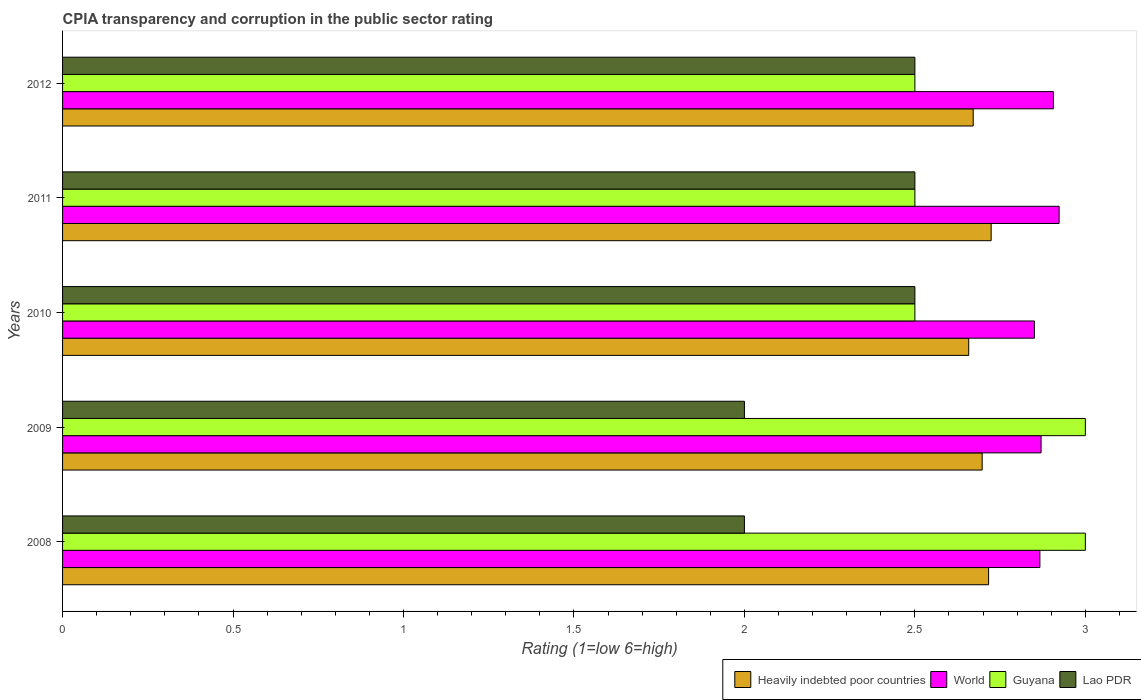Are the number of bars on each tick of the Y-axis equal?
Give a very brief answer. Yes. How many bars are there on the 5th tick from the top?
Give a very brief answer. 4. In how many cases, is the number of bars for a given year not equal to the number of legend labels?
Ensure brevity in your answer.  0. What is the CPIA rating in Heavily indebted poor countries in 2010?
Keep it short and to the point. 2.66. Across all years, what is the maximum CPIA rating in Heavily indebted poor countries?
Ensure brevity in your answer.  2.72. Across all years, what is the minimum CPIA rating in Guyana?
Make the answer very short. 2.5. In which year was the CPIA rating in Heavily indebted poor countries maximum?
Your answer should be very brief. 2011. In which year was the CPIA rating in Guyana minimum?
Your answer should be compact. 2010. What is the difference between the CPIA rating in Heavily indebted poor countries in 2008 and that in 2011?
Give a very brief answer. -0.01. What is the difference between the CPIA rating in Lao PDR in 2009 and the CPIA rating in Guyana in 2012?
Your answer should be very brief. -0.5. In the year 2010, what is the difference between the CPIA rating in World and CPIA rating in Heavily indebted poor countries?
Offer a terse response. 0.19. In how many years, is the CPIA rating in World greater than 0.8 ?
Your answer should be compact. 5. What is the ratio of the CPIA rating in Heavily indebted poor countries in 2008 to that in 2011?
Keep it short and to the point. 1. Is the CPIA rating in Lao PDR in 2010 less than that in 2011?
Make the answer very short. No. Is the difference between the CPIA rating in World in 2008 and 2010 greater than the difference between the CPIA rating in Heavily indebted poor countries in 2008 and 2010?
Provide a short and direct response. No. What is the difference between the highest and the lowest CPIA rating in Heavily indebted poor countries?
Make the answer very short. 0.07. What does the 4th bar from the top in 2009 represents?
Your answer should be very brief. Heavily indebted poor countries. What does the 1st bar from the bottom in 2011 represents?
Offer a terse response. Heavily indebted poor countries. How many bars are there?
Your response must be concise. 20. Are the values on the major ticks of X-axis written in scientific E-notation?
Provide a short and direct response. No. Does the graph contain any zero values?
Provide a short and direct response. No. Where does the legend appear in the graph?
Offer a very short reply. Bottom right. What is the title of the graph?
Keep it short and to the point. CPIA transparency and corruption in the public sector rating. Does "Singapore" appear as one of the legend labels in the graph?
Provide a short and direct response. No. What is the label or title of the X-axis?
Your answer should be compact. Rating (1=low 6=high). What is the Rating (1=low 6=high) of Heavily indebted poor countries in 2008?
Offer a very short reply. 2.72. What is the Rating (1=low 6=high) of World in 2008?
Provide a short and direct response. 2.87. What is the Rating (1=low 6=high) in Lao PDR in 2008?
Your answer should be very brief. 2. What is the Rating (1=low 6=high) of Heavily indebted poor countries in 2009?
Keep it short and to the point. 2.7. What is the Rating (1=low 6=high) in World in 2009?
Provide a short and direct response. 2.87. What is the Rating (1=low 6=high) in Guyana in 2009?
Provide a short and direct response. 3. What is the Rating (1=low 6=high) of Lao PDR in 2009?
Your response must be concise. 2. What is the Rating (1=low 6=high) of Heavily indebted poor countries in 2010?
Ensure brevity in your answer.  2.66. What is the Rating (1=low 6=high) of World in 2010?
Make the answer very short. 2.85. What is the Rating (1=low 6=high) in Lao PDR in 2010?
Ensure brevity in your answer.  2.5. What is the Rating (1=low 6=high) of Heavily indebted poor countries in 2011?
Make the answer very short. 2.72. What is the Rating (1=low 6=high) in World in 2011?
Keep it short and to the point. 2.92. What is the Rating (1=low 6=high) of Lao PDR in 2011?
Provide a short and direct response. 2.5. What is the Rating (1=low 6=high) of Heavily indebted poor countries in 2012?
Provide a short and direct response. 2.67. What is the Rating (1=low 6=high) in World in 2012?
Keep it short and to the point. 2.91. What is the Rating (1=low 6=high) in Lao PDR in 2012?
Provide a short and direct response. 2.5. Across all years, what is the maximum Rating (1=low 6=high) in Heavily indebted poor countries?
Your answer should be compact. 2.72. Across all years, what is the maximum Rating (1=low 6=high) in World?
Your answer should be compact. 2.92. Across all years, what is the maximum Rating (1=low 6=high) of Guyana?
Keep it short and to the point. 3. Across all years, what is the minimum Rating (1=low 6=high) in Heavily indebted poor countries?
Your response must be concise. 2.66. Across all years, what is the minimum Rating (1=low 6=high) in World?
Your answer should be compact. 2.85. Across all years, what is the minimum Rating (1=low 6=high) of Guyana?
Your response must be concise. 2.5. What is the total Rating (1=low 6=high) in Heavily indebted poor countries in the graph?
Provide a succinct answer. 13.47. What is the total Rating (1=low 6=high) in World in the graph?
Offer a very short reply. 14.42. What is the total Rating (1=low 6=high) of Lao PDR in the graph?
Provide a short and direct response. 11.5. What is the difference between the Rating (1=low 6=high) of Heavily indebted poor countries in 2008 and that in 2009?
Your response must be concise. 0.02. What is the difference between the Rating (1=low 6=high) in World in 2008 and that in 2009?
Provide a succinct answer. -0. What is the difference between the Rating (1=low 6=high) in Guyana in 2008 and that in 2009?
Provide a succinct answer. 0. What is the difference between the Rating (1=low 6=high) of Heavily indebted poor countries in 2008 and that in 2010?
Offer a terse response. 0.06. What is the difference between the Rating (1=low 6=high) in World in 2008 and that in 2010?
Your answer should be compact. 0.02. What is the difference between the Rating (1=low 6=high) in Heavily indebted poor countries in 2008 and that in 2011?
Provide a succinct answer. -0.01. What is the difference between the Rating (1=low 6=high) of World in 2008 and that in 2011?
Provide a succinct answer. -0.06. What is the difference between the Rating (1=low 6=high) in Heavily indebted poor countries in 2008 and that in 2012?
Offer a very short reply. 0.05. What is the difference between the Rating (1=low 6=high) of World in 2008 and that in 2012?
Your response must be concise. -0.04. What is the difference between the Rating (1=low 6=high) in Guyana in 2008 and that in 2012?
Make the answer very short. 0.5. What is the difference between the Rating (1=low 6=high) in Heavily indebted poor countries in 2009 and that in 2010?
Ensure brevity in your answer.  0.04. What is the difference between the Rating (1=low 6=high) of World in 2009 and that in 2010?
Ensure brevity in your answer.  0.02. What is the difference between the Rating (1=low 6=high) in Lao PDR in 2009 and that in 2010?
Keep it short and to the point. -0.5. What is the difference between the Rating (1=low 6=high) of Heavily indebted poor countries in 2009 and that in 2011?
Offer a terse response. -0.03. What is the difference between the Rating (1=low 6=high) in World in 2009 and that in 2011?
Offer a very short reply. -0.05. What is the difference between the Rating (1=low 6=high) in Guyana in 2009 and that in 2011?
Offer a terse response. 0.5. What is the difference between the Rating (1=low 6=high) of Heavily indebted poor countries in 2009 and that in 2012?
Keep it short and to the point. 0.03. What is the difference between the Rating (1=low 6=high) in World in 2009 and that in 2012?
Provide a short and direct response. -0.04. What is the difference between the Rating (1=low 6=high) in Heavily indebted poor countries in 2010 and that in 2011?
Give a very brief answer. -0.07. What is the difference between the Rating (1=low 6=high) in World in 2010 and that in 2011?
Your answer should be compact. -0.07. What is the difference between the Rating (1=low 6=high) in Guyana in 2010 and that in 2011?
Provide a short and direct response. 0. What is the difference between the Rating (1=low 6=high) in Lao PDR in 2010 and that in 2011?
Give a very brief answer. 0. What is the difference between the Rating (1=low 6=high) of Heavily indebted poor countries in 2010 and that in 2012?
Your response must be concise. -0.01. What is the difference between the Rating (1=low 6=high) in World in 2010 and that in 2012?
Your response must be concise. -0.06. What is the difference between the Rating (1=low 6=high) in Guyana in 2010 and that in 2012?
Provide a short and direct response. 0. What is the difference between the Rating (1=low 6=high) in Heavily indebted poor countries in 2011 and that in 2012?
Make the answer very short. 0.05. What is the difference between the Rating (1=low 6=high) in World in 2011 and that in 2012?
Your answer should be compact. 0.02. What is the difference between the Rating (1=low 6=high) of Heavily indebted poor countries in 2008 and the Rating (1=low 6=high) of World in 2009?
Make the answer very short. -0.15. What is the difference between the Rating (1=low 6=high) in Heavily indebted poor countries in 2008 and the Rating (1=low 6=high) in Guyana in 2009?
Provide a short and direct response. -0.28. What is the difference between the Rating (1=low 6=high) in Heavily indebted poor countries in 2008 and the Rating (1=low 6=high) in Lao PDR in 2009?
Make the answer very short. 0.72. What is the difference between the Rating (1=low 6=high) in World in 2008 and the Rating (1=low 6=high) in Guyana in 2009?
Your answer should be very brief. -0.13. What is the difference between the Rating (1=low 6=high) in World in 2008 and the Rating (1=low 6=high) in Lao PDR in 2009?
Keep it short and to the point. 0.87. What is the difference between the Rating (1=low 6=high) in Guyana in 2008 and the Rating (1=low 6=high) in Lao PDR in 2009?
Offer a very short reply. 1. What is the difference between the Rating (1=low 6=high) of Heavily indebted poor countries in 2008 and the Rating (1=low 6=high) of World in 2010?
Keep it short and to the point. -0.13. What is the difference between the Rating (1=low 6=high) in Heavily indebted poor countries in 2008 and the Rating (1=low 6=high) in Guyana in 2010?
Ensure brevity in your answer.  0.22. What is the difference between the Rating (1=low 6=high) in Heavily indebted poor countries in 2008 and the Rating (1=low 6=high) in Lao PDR in 2010?
Offer a terse response. 0.22. What is the difference between the Rating (1=low 6=high) of World in 2008 and the Rating (1=low 6=high) of Guyana in 2010?
Offer a terse response. 0.37. What is the difference between the Rating (1=low 6=high) in World in 2008 and the Rating (1=low 6=high) in Lao PDR in 2010?
Your answer should be compact. 0.37. What is the difference between the Rating (1=low 6=high) in Heavily indebted poor countries in 2008 and the Rating (1=low 6=high) in World in 2011?
Keep it short and to the point. -0.21. What is the difference between the Rating (1=low 6=high) of Heavily indebted poor countries in 2008 and the Rating (1=low 6=high) of Guyana in 2011?
Offer a very short reply. 0.22. What is the difference between the Rating (1=low 6=high) in Heavily indebted poor countries in 2008 and the Rating (1=low 6=high) in Lao PDR in 2011?
Your answer should be compact. 0.22. What is the difference between the Rating (1=low 6=high) in World in 2008 and the Rating (1=low 6=high) in Guyana in 2011?
Keep it short and to the point. 0.37. What is the difference between the Rating (1=low 6=high) in World in 2008 and the Rating (1=low 6=high) in Lao PDR in 2011?
Provide a short and direct response. 0.37. What is the difference between the Rating (1=low 6=high) of Heavily indebted poor countries in 2008 and the Rating (1=low 6=high) of World in 2012?
Your answer should be very brief. -0.19. What is the difference between the Rating (1=low 6=high) of Heavily indebted poor countries in 2008 and the Rating (1=low 6=high) of Guyana in 2012?
Ensure brevity in your answer.  0.22. What is the difference between the Rating (1=low 6=high) in Heavily indebted poor countries in 2008 and the Rating (1=low 6=high) in Lao PDR in 2012?
Give a very brief answer. 0.22. What is the difference between the Rating (1=low 6=high) of World in 2008 and the Rating (1=low 6=high) of Guyana in 2012?
Offer a terse response. 0.37. What is the difference between the Rating (1=low 6=high) of World in 2008 and the Rating (1=low 6=high) of Lao PDR in 2012?
Make the answer very short. 0.37. What is the difference between the Rating (1=low 6=high) of Heavily indebted poor countries in 2009 and the Rating (1=low 6=high) of World in 2010?
Your answer should be very brief. -0.15. What is the difference between the Rating (1=low 6=high) of Heavily indebted poor countries in 2009 and the Rating (1=low 6=high) of Guyana in 2010?
Keep it short and to the point. 0.2. What is the difference between the Rating (1=low 6=high) in Heavily indebted poor countries in 2009 and the Rating (1=low 6=high) in Lao PDR in 2010?
Offer a terse response. 0.2. What is the difference between the Rating (1=low 6=high) of World in 2009 and the Rating (1=low 6=high) of Guyana in 2010?
Ensure brevity in your answer.  0.37. What is the difference between the Rating (1=low 6=high) of World in 2009 and the Rating (1=low 6=high) of Lao PDR in 2010?
Your response must be concise. 0.37. What is the difference between the Rating (1=low 6=high) in Heavily indebted poor countries in 2009 and the Rating (1=low 6=high) in World in 2011?
Ensure brevity in your answer.  -0.23. What is the difference between the Rating (1=low 6=high) of Heavily indebted poor countries in 2009 and the Rating (1=low 6=high) of Guyana in 2011?
Offer a terse response. 0.2. What is the difference between the Rating (1=low 6=high) of Heavily indebted poor countries in 2009 and the Rating (1=low 6=high) of Lao PDR in 2011?
Your answer should be very brief. 0.2. What is the difference between the Rating (1=low 6=high) in World in 2009 and the Rating (1=low 6=high) in Guyana in 2011?
Your answer should be very brief. 0.37. What is the difference between the Rating (1=low 6=high) of World in 2009 and the Rating (1=low 6=high) of Lao PDR in 2011?
Keep it short and to the point. 0.37. What is the difference between the Rating (1=low 6=high) of Heavily indebted poor countries in 2009 and the Rating (1=low 6=high) of World in 2012?
Your answer should be very brief. -0.21. What is the difference between the Rating (1=low 6=high) in Heavily indebted poor countries in 2009 and the Rating (1=low 6=high) in Guyana in 2012?
Offer a very short reply. 0.2. What is the difference between the Rating (1=low 6=high) of Heavily indebted poor countries in 2009 and the Rating (1=low 6=high) of Lao PDR in 2012?
Provide a succinct answer. 0.2. What is the difference between the Rating (1=low 6=high) of World in 2009 and the Rating (1=low 6=high) of Guyana in 2012?
Provide a short and direct response. 0.37. What is the difference between the Rating (1=low 6=high) of World in 2009 and the Rating (1=low 6=high) of Lao PDR in 2012?
Keep it short and to the point. 0.37. What is the difference between the Rating (1=low 6=high) of Guyana in 2009 and the Rating (1=low 6=high) of Lao PDR in 2012?
Provide a short and direct response. 0.5. What is the difference between the Rating (1=low 6=high) in Heavily indebted poor countries in 2010 and the Rating (1=low 6=high) in World in 2011?
Provide a succinct answer. -0.27. What is the difference between the Rating (1=low 6=high) of Heavily indebted poor countries in 2010 and the Rating (1=low 6=high) of Guyana in 2011?
Your answer should be very brief. 0.16. What is the difference between the Rating (1=low 6=high) of Heavily indebted poor countries in 2010 and the Rating (1=low 6=high) of Lao PDR in 2011?
Ensure brevity in your answer.  0.16. What is the difference between the Rating (1=low 6=high) in World in 2010 and the Rating (1=low 6=high) in Guyana in 2011?
Provide a succinct answer. 0.35. What is the difference between the Rating (1=low 6=high) of World in 2010 and the Rating (1=low 6=high) of Lao PDR in 2011?
Offer a terse response. 0.35. What is the difference between the Rating (1=low 6=high) in Guyana in 2010 and the Rating (1=low 6=high) in Lao PDR in 2011?
Provide a succinct answer. 0. What is the difference between the Rating (1=low 6=high) of Heavily indebted poor countries in 2010 and the Rating (1=low 6=high) of World in 2012?
Your answer should be compact. -0.25. What is the difference between the Rating (1=low 6=high) in Heavily indebted poor countries in 2010 and the Rating (1=low 6=high) in Guyana in 2012?
Give a very brief answer. 0.16. What is the difference between the Rating (1=low 6=high) of Heavily indebted poor countries in 2010 and the Rating (1=low 6=high) of Lao PDR in 2012?
Your answer should be very brief. 0.16. What is the difference between the Rating (1=low 6=high) in World in 2010 and the Rating (1=low 6=high) in Guyana in 2012?
Offer a terse response. 0.35. What is the difference between the Rating (1=low 6=high) in World in 2010 and the Rating (1=low 6=high) in Lao PDR in 2012?
Offer a very short reply. 0.35. What is the difference between the Rating (1=low 6=high) in Heavily indebted poor countries in 2011 and the Rating (1=low 6=high) in World in 2012?
Your response must be concise. -0.18. What is the difference between the Rating (1=low 6=high) in Heavily indebted poor countries in 2011 and the Rating (1=low 6=high) in Guyana in 2012?
Give a very brief answer. 0.22. What is the difference between the Rating (1=low 6=high) in Heavily indebted poor countries in 2011 and the Rating (1=low 6=high) in Lao PDR in 2012?
Give a very brief answer. 0.22. What is the difference between the Rating (1=low 6=high) of World in 2011 and the Rating (1=low 6=high) of Guyana in 2012?
Offer a very short reply. 0.42. What is the difference between the Rating (1=low 6=high) of World in 2011 and the Rating (1=low 6=high) of Lao PDR in 2012?
Keep it short and to the point. 0.42. What is the difference between the Rating (1=low 6=high) in Guyana in 2011 and the Rating (1=low 6=high) in Lao PDR in 2012?
Your response must be concise. 0. What is the average Rating (1=low 6=high) of Heavily indebted poor countries per year?
Provide a short and direct response. 2.69. What is the average Rating (1=low 6=high) in World per year?
Give a very brief answer. 2.88. What is the average Rating (1=low 6=high) of Guyana per year?
Make the answer very short. 2.7. In the year 2008, what is the difference between the Rating (1=low 6=high) in Heavily indebted poor countries and Rating (1=low 6=high) in World?
Provide a succinct answer. -0.15. In the year 2008, what is the difference between the Rating (1=low 6=high) in Heavily indebted poor countries and Rating (1=low 6=high) in Guyana?
Provide a short and direct response. -0.28. In the year 2008, what is the difference between the Rating (1=low 6=high) of Heavily indebted poor countries and Rating (1=low 6=high) of Lao PDR?
Provide a short and direct response. 0.72. In the year 2008, what is the difference between the Rating (1=low 6=high) in World and Rating (1=low 6=high) in Guyana?
Your answer should be very brief. -0.13. In the year 2008, what is the difference between the Rating (1=low 6=high) of World and Rating (1=low 6=high) of Lao PDR?
Your answer should be very brief. 0.87. In the year 2008, what is the difference between the Rating (1=low 6=high) of Guyana and Rating (1=low 6=high) of Lao PDR?
Provide a short and direct response. 1. In the year 2009, what is the difference between the Rating (1=low 6=high) of Heavily indebted poor countries and Rating (1=low 6=high) of World?
Your answer should be compact. -0.17. In the year 2009, what is the difference between the Rating (1=low 6=high) of Heavily indebted poor countries and Rating (1=low 6=high) of Guyana?
Your answer should be very brief. -0.3. In the year 2009, what is the difference between the Rating (1=low 6=high) of Heavily indebted poor countries and Rating (1=low 6=high) of Lao PDR?
Your response must be concise. 0.7. In the year 2009, what is the difference between the Rating (1=low 6=high) of World and Rating (1=low 6=high) of Guyana?
Make the answer very short. -0.13. In the year 2009, what is the difference between the Rating (1=low 6=high) in World and Rating (1=low 6=high) in Lao PDR?
Provide a succinct answer. 0.87. In the year 2009, what is the difference between the Rating (1=low 6=high) in Guyana and Rating (1=low 6=high) in Lao PDR?
Keep it short and to the point. 1. In the year 2010, what is the difference between the Rating (1=low 6=high) in Heavily indebted poor countries and Rating (1=low 6=high) in World?
Provide a short and direct response. -0.19. In the year 2010, what is the difference between the Rating (1=low 6=high) of Heavily indebted poor countries and Rating (1=low 6=high) of Guyana?
Provide a succinct answer. 0.16. In the year 2010, what is the difference between the Rating (1=low 6=high) of Heavily indebted poor countries and Rating (1=low 6=high) of Lao PDR?
Provide a short and direct response. 0.16. In the year 2010, what is the difference between the Rating (1=low 6=high) of World and Rating (1=low 6=high) of Guyana?
Keep it short and to the point. 0.35. In the year 2010, what is the difference between the Rating (1=low 6=high) in World and Rating (1=low 6=high) in Lao PDR?
Give a very brief answer. 0.35. In the year 2011, what is the difference between the Rating (1=low 6=high) in Heavily indebted poor countries and Rating (1=low 6=high) in World?
Your answer should be very brief. -0.2. In the year 2011, what is the difference between the Rating (1=low 6=high) in Heavily indebted poor countries and Rating (1=low 6=high) in Guyana?
Keep it short and to the point. 0.22. In the year 2011, what is the difference between the Rating (1=low 6=high) of Heavily indebted poor countries and Rating (1=low 6=high) of Lao PDR?
Provide a short and direct response. 0.22. In the year 2011, what is the difference between the Rating (1=low 6=high) of World and Rating (1=low 6=high) of Guyana?
Ensure brevity in your answer.  0.42. In the year 2011, what is the difference between the Rating (1=low 6=high) in World and Rating (1=low 6=high) in Lao PDR?
Your answer should be compact. 0.42. In the year 2011, what is the difference between the Rating (1=low 6=high) in Guyana and Rating (1=low 6=high) in Lao PDR?
Keep it short and to the point. 0. In the year 2012, what is the difference between the Rating (1=low 6=high) in Heavily indebted poor countries and Rating (1=low 6=high) in World?
Your answer should be very brief. -0.24. In the year 2012, what is the difference between the Rating (1=low 6=high) of Heavily indebted poor countries and Rating (1=low 6=high) of Guyana?
Your response must be concise. 0.17. In the year 2012, what is the difference between the Rating (1=low 6=high) of Heavily indebted poor countries and Rating (1=low 6=high) of Lao PDR?
Your answer should be compact. 0.17. In the year 2012, what is the difference between the Rating (1=low 6=high) of World and Rating (1=low 6=high) of Guyana?
Provide a short and direct response. 0.41. In the year 2012, what is the difference between the Rating (1=low 6=high) of World and Rating (1=low 6=high) of Lao PDR?
Your answer should be very brief. 0.41. In the year 2012, what is the difference between the Rating (1=low 6=high) in Guyana and Rating (1=low 6=high) in Lao PDR?
Make the answer very short. 0. What is the ratio of the Rating (1=low 6=high) in World in 2008 to that in 2009?
Provide a short and direct response. 1. What is the ratio of the Rating (1=low 6=high) of Lao PDR in 2008 to that in 2009?
Provide a succinct answer. 1. What is the ratio of the Rating (1=low 6=high) in Heavily indebted poor countries in 2008 to that in 2010?
Offer a terse response. 1.02. What is the ratio of the Rating (1=low 6=high) in World in 2008 to that in 2010?
Your response must be concise. 1.01. What is the ratio of the Rating (1=low 6=high) in Guyana in 2008 to that in 2010?
Make the answer very short. 1.2. What is the ratio of the Rating (1=low 6=high) of Lao PDR in 2008 to that in 2010?
Your answer should be very brief. 0.8. What is the ratio of the Rating (1=low 6=high) in World in 2008 to that in 2011?
Provide a short and direct response. 0.98. What is the ratio of the Rating (1=low 6=high) of Heavily indebted poor countries in 2008 to that in 2012?
Make the answer very short. 1.02. What is the ratio of the Rating (1=low 6=high) in World in 2008 to that in 2012?
Your answer should be compact. 0.99. What is the ratio of the Rating (1=low 6=high) in Guyana in 2008 to that in 2012?
Offer a terse response. 1.2. What is the ratio of the Rating (1=low 6=high) of Lao PDR in 2008 to that in 2012?
Ensure brevity in your answer.  0.8. What is the ratio of the Rating (1=low 6=high) of Heavily indebted poor countries in 2009 to that in 2010?
Keep it short and to the point. 1.01. What is the ratio of the Rating (1=low 6=high) in World in 2009 to that in 2010?
Offer a very short reply. 1.01. What is the ratio of the Rating (1=low 6=high) in Lao PDR in 2009 to that in 2010?
Give a very brief answer. 0.8. What is the ratio of the Rating (1=low 6=high) of Heavily indebted poor countries in 2009 to that in 2011?
Provide a short and direct response. 0.99. What is the ratio of the Rating (1=low 6=high) of World in 2009 to that in 2011?
Provide a short and direct response. 0.98. What is the ratio of the Rating (1=low 6=high) of Lao PDR in 2009 to that in 2011?
Provide a succinct answer. 0.8. What is the ratio of the Rating (1=low 6=high) of Heavily indebted poor countries in 2009 to that in 2012?
Ensure brevity in your answer.  1.01. What is the ratio of the Rating (1=low 6=high) in World in 2009 to that in 2012?
Your answer should be very brief. 0.99. What is the ratio of the Rating (1=low 6=high) in Guyana in 2009 to that in 2012?
Keep it short and to the point. 1.2. What is the ratio of the Rating (1=low 6=high) in Lao PDR in 2009 to that in 2012?
Provide a succinct answer. 0.8. What is the ratio of the Rating (1=low 6=high) of Heavily indebted poor countries in 2010 to that in 2011?
Give a very brief answer. 0.98. What is the ratio of the Rating (1=low 6=high) in World in 2010 to that in 2011?
Give a very brief answer. 0.98. What is the ratio of the Rating (1=low 6=high) in Guyana in 2010 to that in 2011?
Make the answer very short. 1. What is the ratio of the Rating (1=low 6=high) in World in 2010 to that in 2012?
Your response must be concise. 0.98. What is the ratio of the Rating (1=low 6=high) of Guyana in 2010 to that in 2012?
Your response must be concise. 1. What is the ratio of the Rating (1=low 6=high) of Lao PDR in 2010 to that in 2012?
Offer a terse response. 1. What is the ratio of the Rating (1=low 6=high) of Heavily indebted poor countries in 2011 to that in 2012?
Offer a very short reply. 1.02. What is the ratio of the Rating (1=low 6=high) of Guyana in 2011 to that in 2012?
Your answer should be very brief. 1. What is the ratio of the Rating (1=low 6=high) in Lao PDR in 2011 to that in 2012?
Provide a short and direct response. 1. What is the difference between the highest and the second highest Rating (1=low 6=high) of Heavily indebted poor countries?
Your answer should be very brief. 0.01. What is the difference between the highest and the second highest Rating (1=low 6=high) of World?
Your answer should be very brief. 0.02. What is the difference between the highest and the second highest Rating (1=low 6=high) in Lao PDR?
Offer a very short reply. 0. What is the difference between the highest and the lowest Rating (1=low 6=high) in Heavily indebted poor countries?
Provide a short and direct response. 0.07. What is the difference between the highest and the lowest Rating (1=low 6=high) in World?
Ensure brevity in your answer.  0.07. What is the difference between the highest and the lowest Rating (1=low 6=high) in Guyana?
Provide a succinct answer. 0.5. What is the difference between the highest and the lowest Rating (1=low 6=high) of Lao PDR?
Your response must be concise. 0.5. 